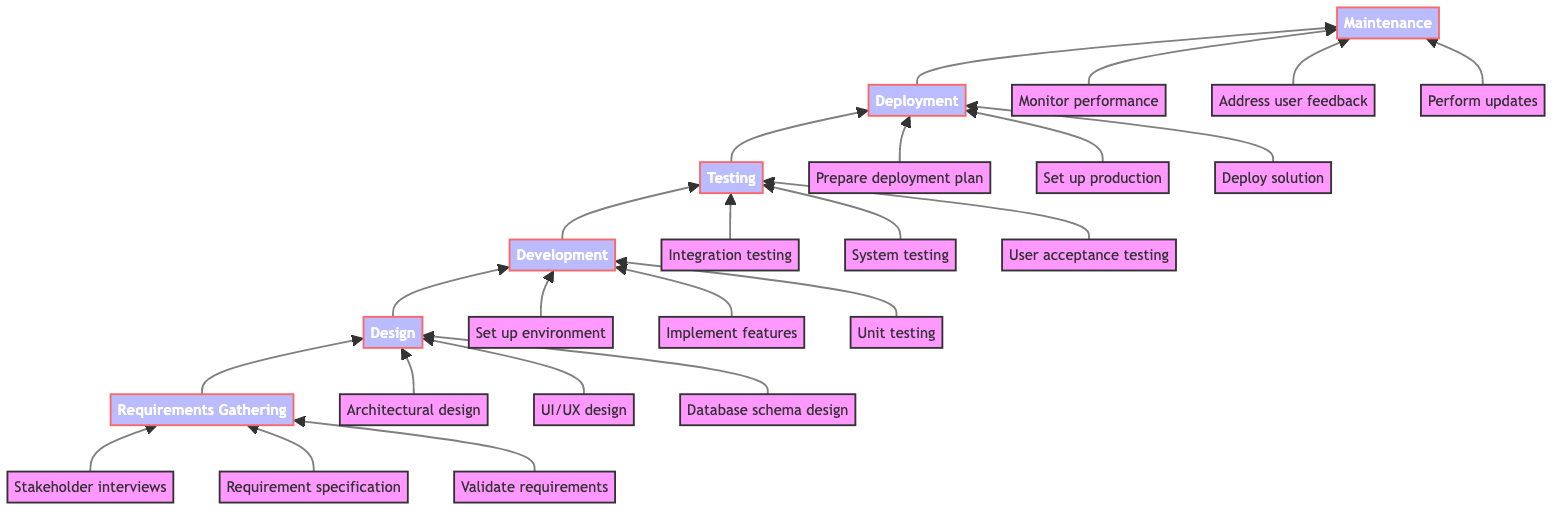What's the first stage in the software development lifecycle? The diagram starts with the first node labeled "Requirements Gathering," indicating it is the initial stage of the lifecycle.
Answer: Requirements Gathering How many stages are there in the software development project lifecycle? Counting the stages listed in the diagram, there are a total of six stages: Requirements Gathering, Design, Development, Testing, Deployment, and Maintenance.
Answer: Six Which stage comes directly after Development? In the flow chart, you can see the arrow pointing from "Development" to "Testing," indicating that Testing is the subsequent stage.
Answer: Testing What tasks are involved in the Design stage? The diagram lists four tasks under the Design stage: Architectural design, UI/UX design, Database schema design, and Review design with stakeholders.
Answer: Architectural design, UI/UX design, Database schema design, Review design with stakeholders How does Testing ensure the software meets requirements? The Testing stage includes User acceptance testing, which specifically assesses whether the software fulfills the documented needs and requirements from earlier stages.
Answer: User acceptance testing What is the last stage in the waterfall flow? The last node at the top of the flow chart is labeled "Maintenance," indicating that it is the final stage of the lifecycle.
Answer: Maintenance How do you identify tasks belonging to the Deployment stage? In the diagram, the Deployment stage is directly connected to four tasks listed beneath it: Prepare deployment plan, Set up production environment, Deploy solution, and Monitor initial launch, showing these tasks are associated with Deployment.
Answer: Prepare deployment plan, Set up production environment, Deploy solution, Monitor initial launch In which stage does bug fixing occur? Bug fixing is mentioned as one of the tasks within the Testing stage, indicating that it is where issues are resolved.
Answer: Testing What type of flow chart is represented in this lifecycle diagram? The diagram is specifically categorized as a Bottom to Top Flow Chart, where all arrows point upward, illustrating the flow of the software development lifecycle stages from bottom to top.
Answer: Bottom to Top Flow Chart 